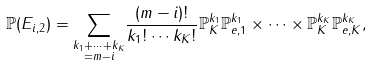Convert formula to latex. <formula><loc_0><loc_0><loc_500><loc_500>\mathbb { P } ( { E } _ { i , 2 } ) & = \underset { \substack { k _ { 1 } + \cdots + k _ { K } \\ = m - i } } { \sum } \frac { ( m - i ) ! } { k _ { 1 } ! \cdots k _ { K } ! } \mathbb { P } _ { K } ^ { k _ { 1 } } \mathbb { P } _ { e , 1 } ^ { k _ { 1 } } \times \cdots \times \mathbb { P } _ { K } ^ { k _ { K } } \mathbb { P } _ { e , K } ^ { k _ { K } } ,</formula> 